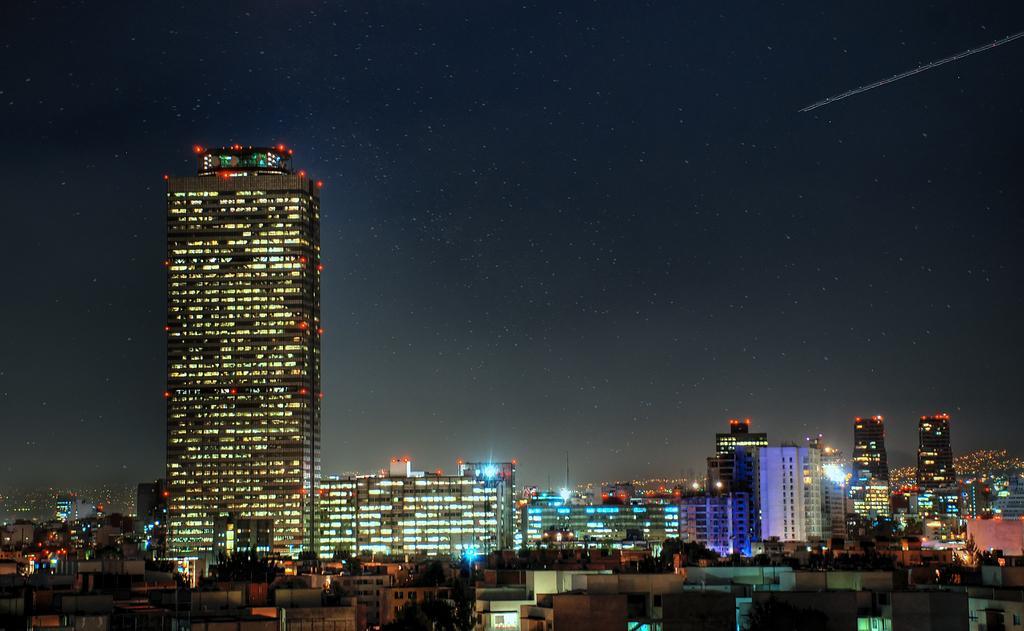Can you describe this image briefly? This picture is clicked outside. In the foreground we can see the buildings, trees and the skyscrapers, and we can see the lights. In the background we can see the sky, and we can see some other items. 